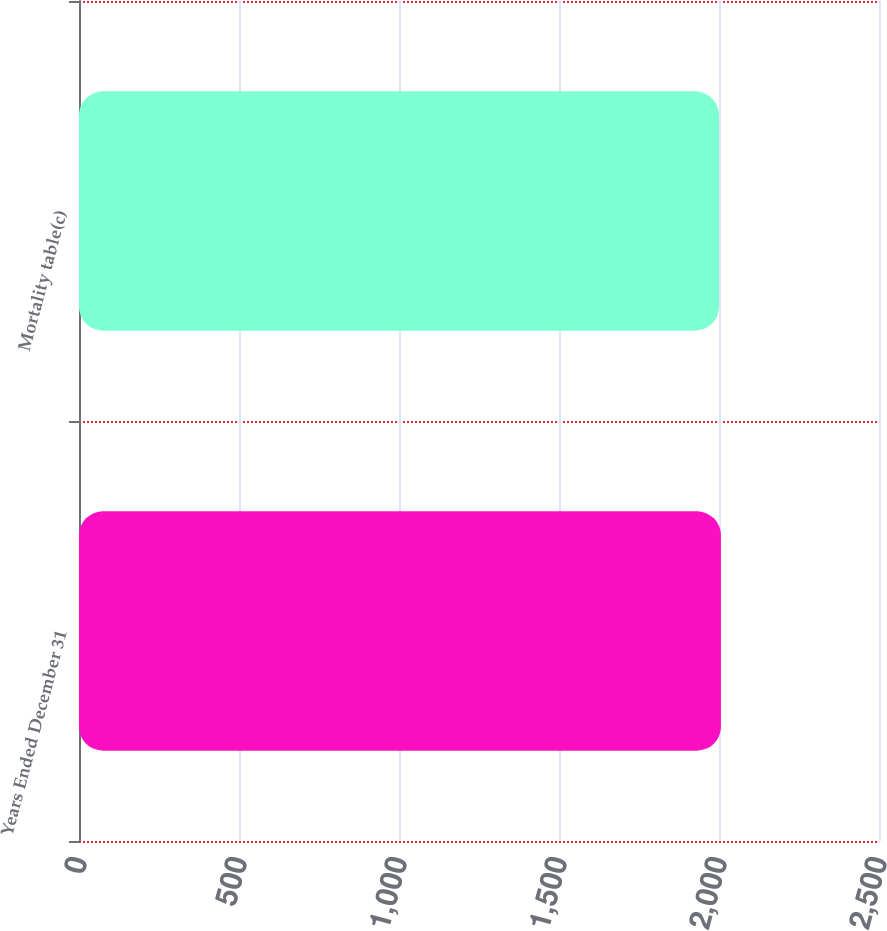<chart> <loc_0><loc_0><loc_500><loc_500><bar_chart><fcel>Years Ended December 31<fcel>Mortality table(c)<nl><fcel>2006<fcel>2000<nl></chart> 